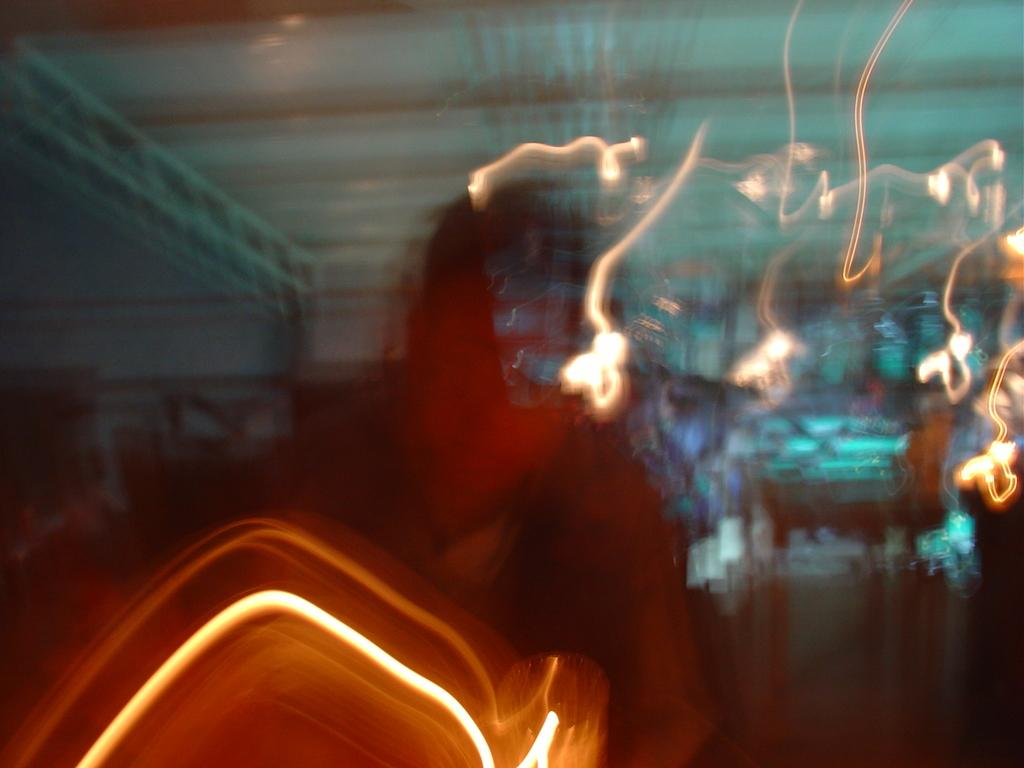What is the overall quality of the image? The image is blurred. What type of lights can be seen in the image? There are multi-color lights visible in the image. Is there a tail visible in the image? No, there is no tail present in the image. Can you see a volcano in the image? No, there is no volcano present in the image. 